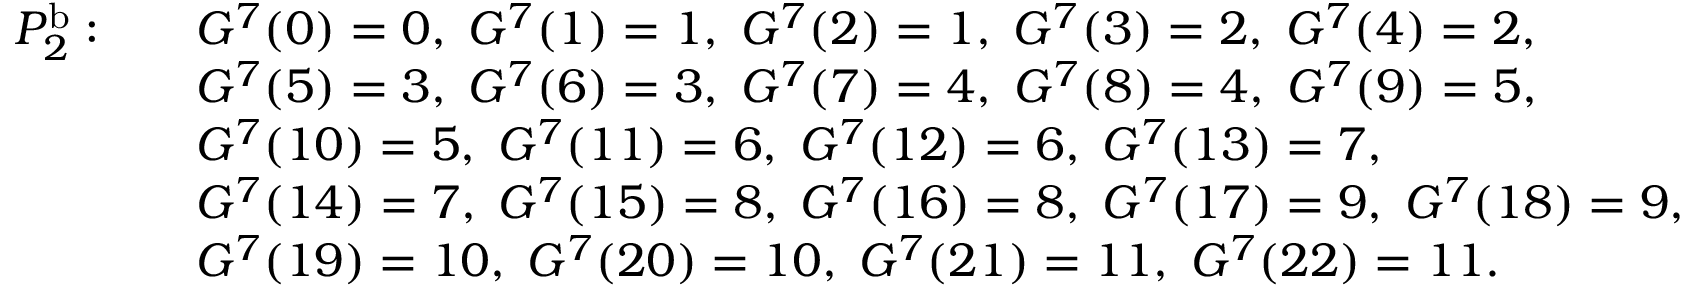<formula> <loc_0><loc_0><loc_500><loc_500>\begin{array} { r l } { P _ { 2 } ^ { b } \colon \quad } & { G ^ { 7 } ( 0 ) = 0 , \, G ^ { 7 } ( 1 ) = 1 , \, G ^ { 7 } ( 2 ) = 1 , \, G ^ { 7 } ( 3 ) = 2 , \, G ^ { 7 } ( 4 ) = 2 , } \\ & { G ^ { 7 } ( 5 ) = 3 , \, G ^ { 7 } ( 6 ) = 3 , \, G ^ { 7 } ( 7 ) = 4 , \, G ^ { 7 } ( 8 ) = 4 , \, G ^ { 7 } ( 9 ) = 5 , } \\ & { G ^ { 7 } ( 1 0 ) = 5 , \, G ^ { 7 } ( 1 1 ) = 6 , \, G ^ { 7 } ( 1 2 ) = 6 , \, G ^ { 7 } ( 1 3 ) = 7 , } \\ & { G ^ { 7 } ( 1 4 ) = 7 , \, G ^ { 7 } ( 1 5 ) = 8 , \, G ^ { 7 } ( 1 6 ) = 8 , \, G ^ { 7 } ( 1 7 ) = 9 , \, G ^ { 7 } ( 1 8 ) = 9 , } \\ & { G ^ { 7 } ( 1 9 ) = 1 0 , \, G ^ { 7 } ( 2 0 ) = 1 0 , \, G ^ { 7 } ( 2 1 ) = 1 1 , \, G ^ { 7 } ( 2 2 ) = 1 1 . \, } \end{array}</formula> 